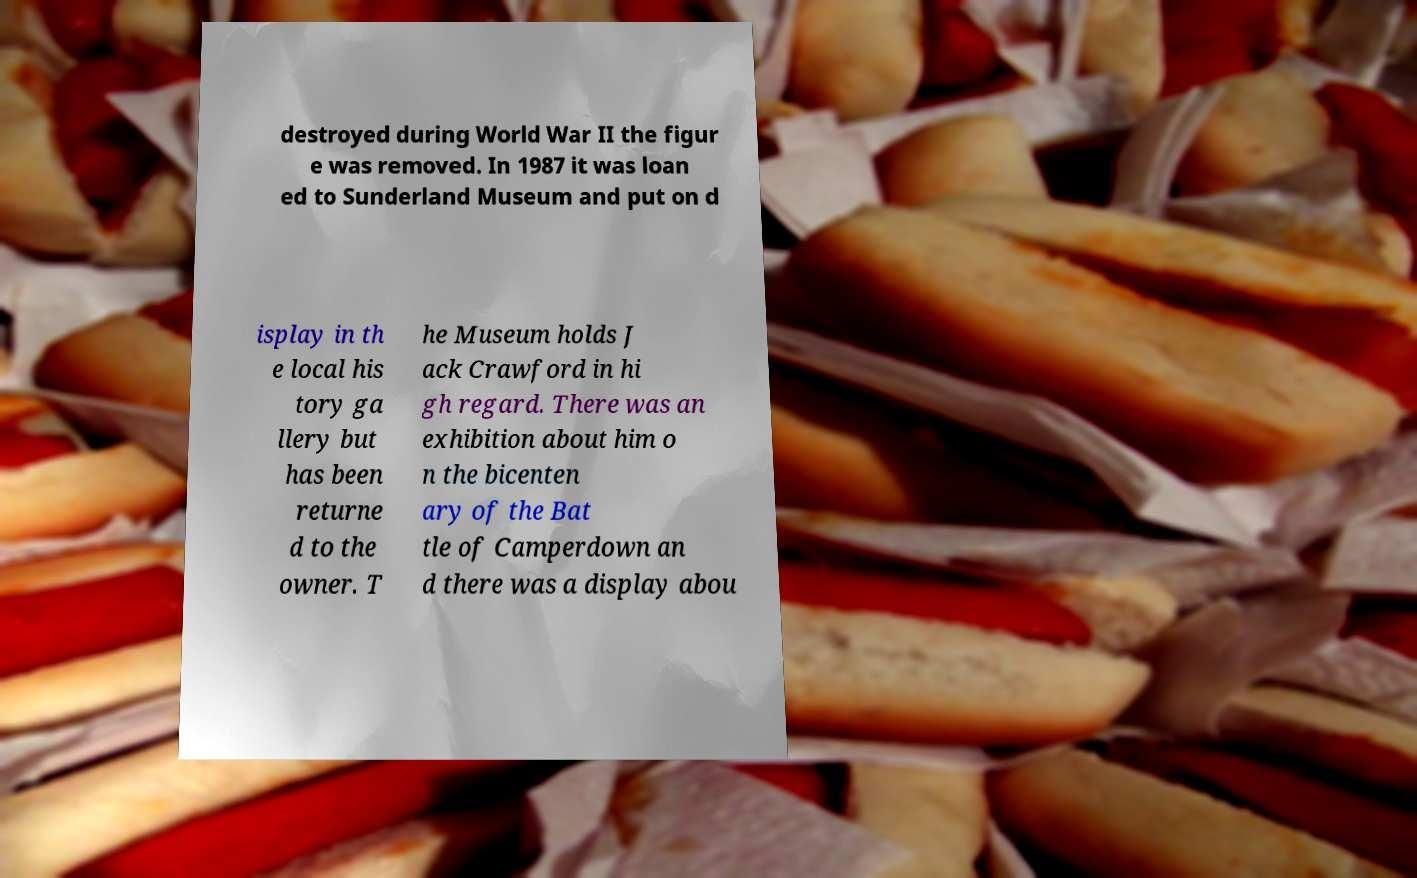What messages or text are displayed in this image? I need them in a readable, typed format. destroyed during World War II the figur e was removed. In 1987 it was loan ed to Sunderland Museum and put on d isplay in th e local his tory ga llery but has been returne d to the owner. T he Museum holds J ack Crawford in hi gh regard. There was an exhibition about him o n the bicenten ary of the Bat tle of Camperdown an d there was a display abou 